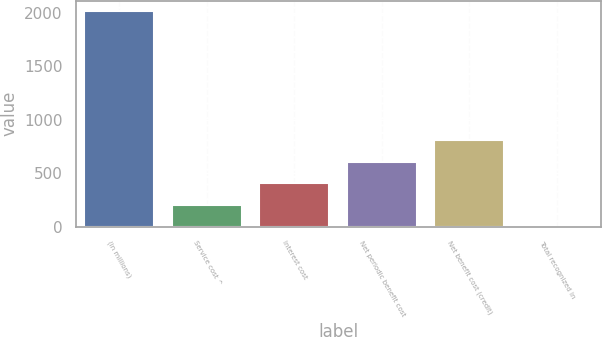Convert chart to OTSL. <chart><loc_0><loc_0><loc_500><loc_500><bar_chart><fcel>(in millions)<fcel>Service cost ^<fcel>Interest cost<fcel>Net periodic benefit cost<fcel>Net benefit cost (credit)<fcel>Total recognized in<nl><fcel>2016<fcel>202.5<fcel>404<fcel>605.5<fcel>807<fcel>1<nl></chart> 